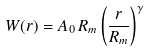Convert formula to latex. <formula><loc_0><loc_0><loc_500><loc_500>W ( r ) = A _ { 0 } \, R _ { m } \left ( \frac { r } { R _ { m } } \right ) ^ { \gamma }</formula> 